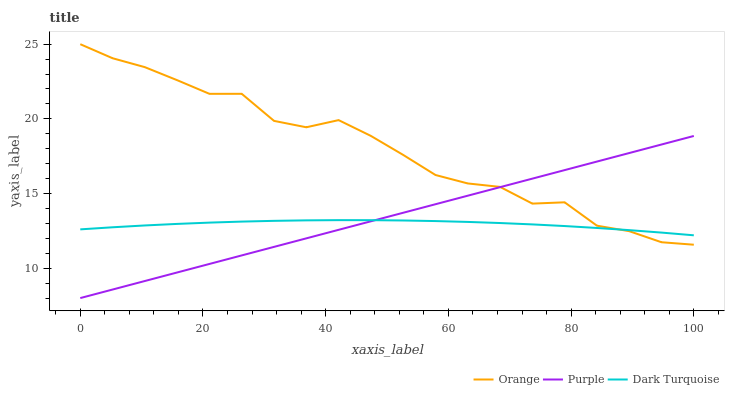Does Dark Turquoise have the minimum area under the curve?
Answer yes or no. Yes. Does Orange have the maximum area under the curve?
Answer yes or no. Yes. Does Purple have the minimum area under the curve?
Answer yes or no. No. Does Purple have the maximum area under the curve?
Answer yes or no. No. Is Purple the smoothest?
Answer yes or no. Yes. Is Orange the roughest?
Answer yes or no. Yes. Is Dark Turquoise the smoothest?
Answer yes or no. No. Is Dark Turquoise the roughest?
Answer yes or no. No. Does Dark Turquoise have the lowest value?
Answer yes or no. No. Does Purple have the highest value?
Answer yes or no. No. 